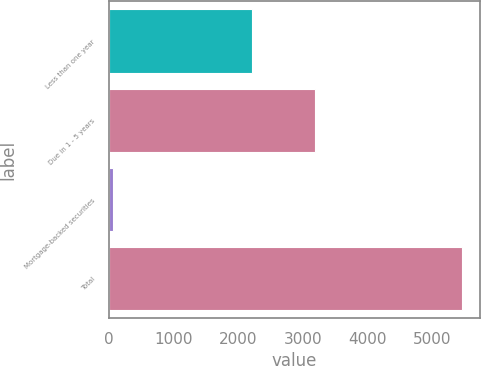<chart> <loc_0><loc_0><loc_500><loc_500><bar_chart><fcel>Less than one year<fcel>Due in 1 - 5 years<fcel>Mortgage-backed securities<fcel>Total<nl><fcel>2209<fcel>3194<fcel>65<fcel>5468<nl></chart> 